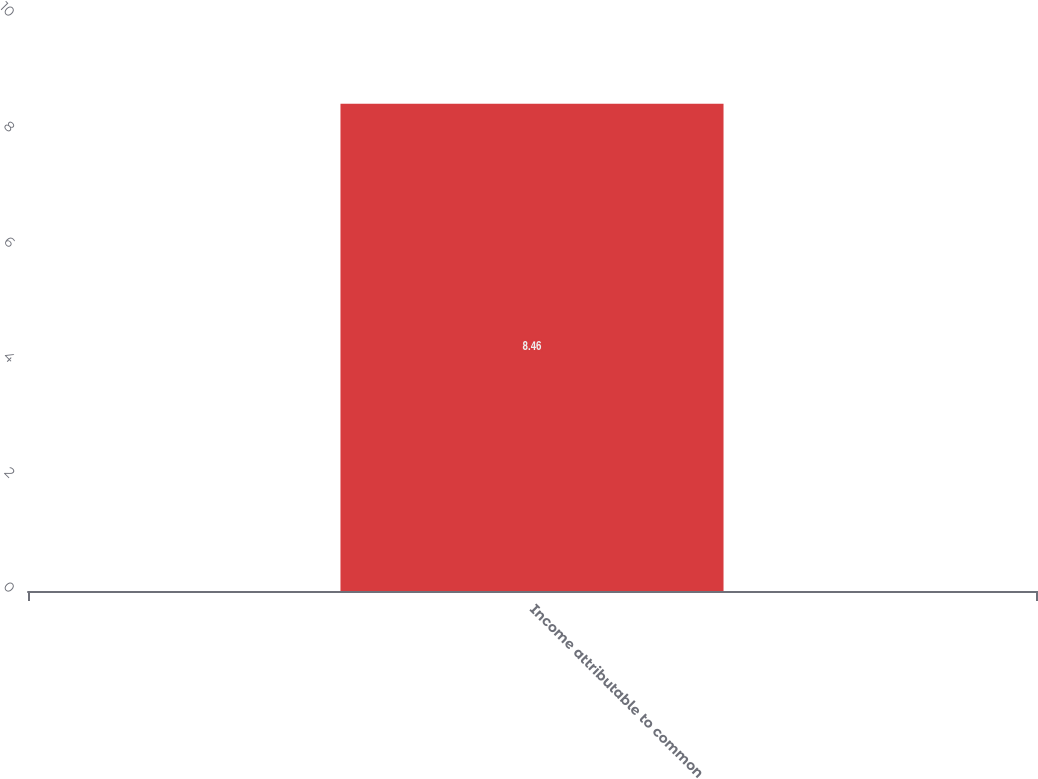Convert chart. <chart><loc_0><loc_0><loc_500><loc_500><bar_chart><fcel>Income attributable to common<nl><fcel>8.46<nl></chart> 